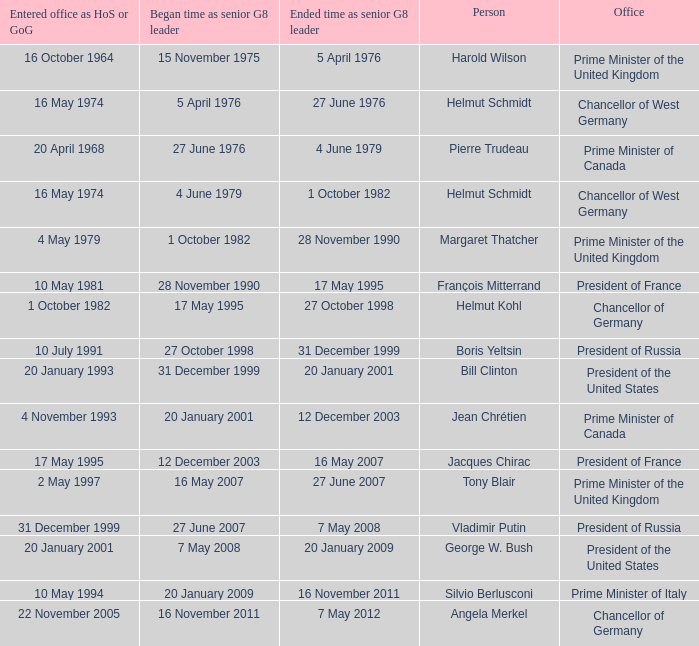When did jacques chirac discontinue his role as a g8 leader? 16 May 2007. 